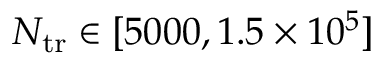<formula> <loc_0><loc_0><loc_500><loc_500>N _ { t r } \in [ 5 0 0 0 , 1 . 5 \times 1 0 ^ { 5 } ]</formula> 